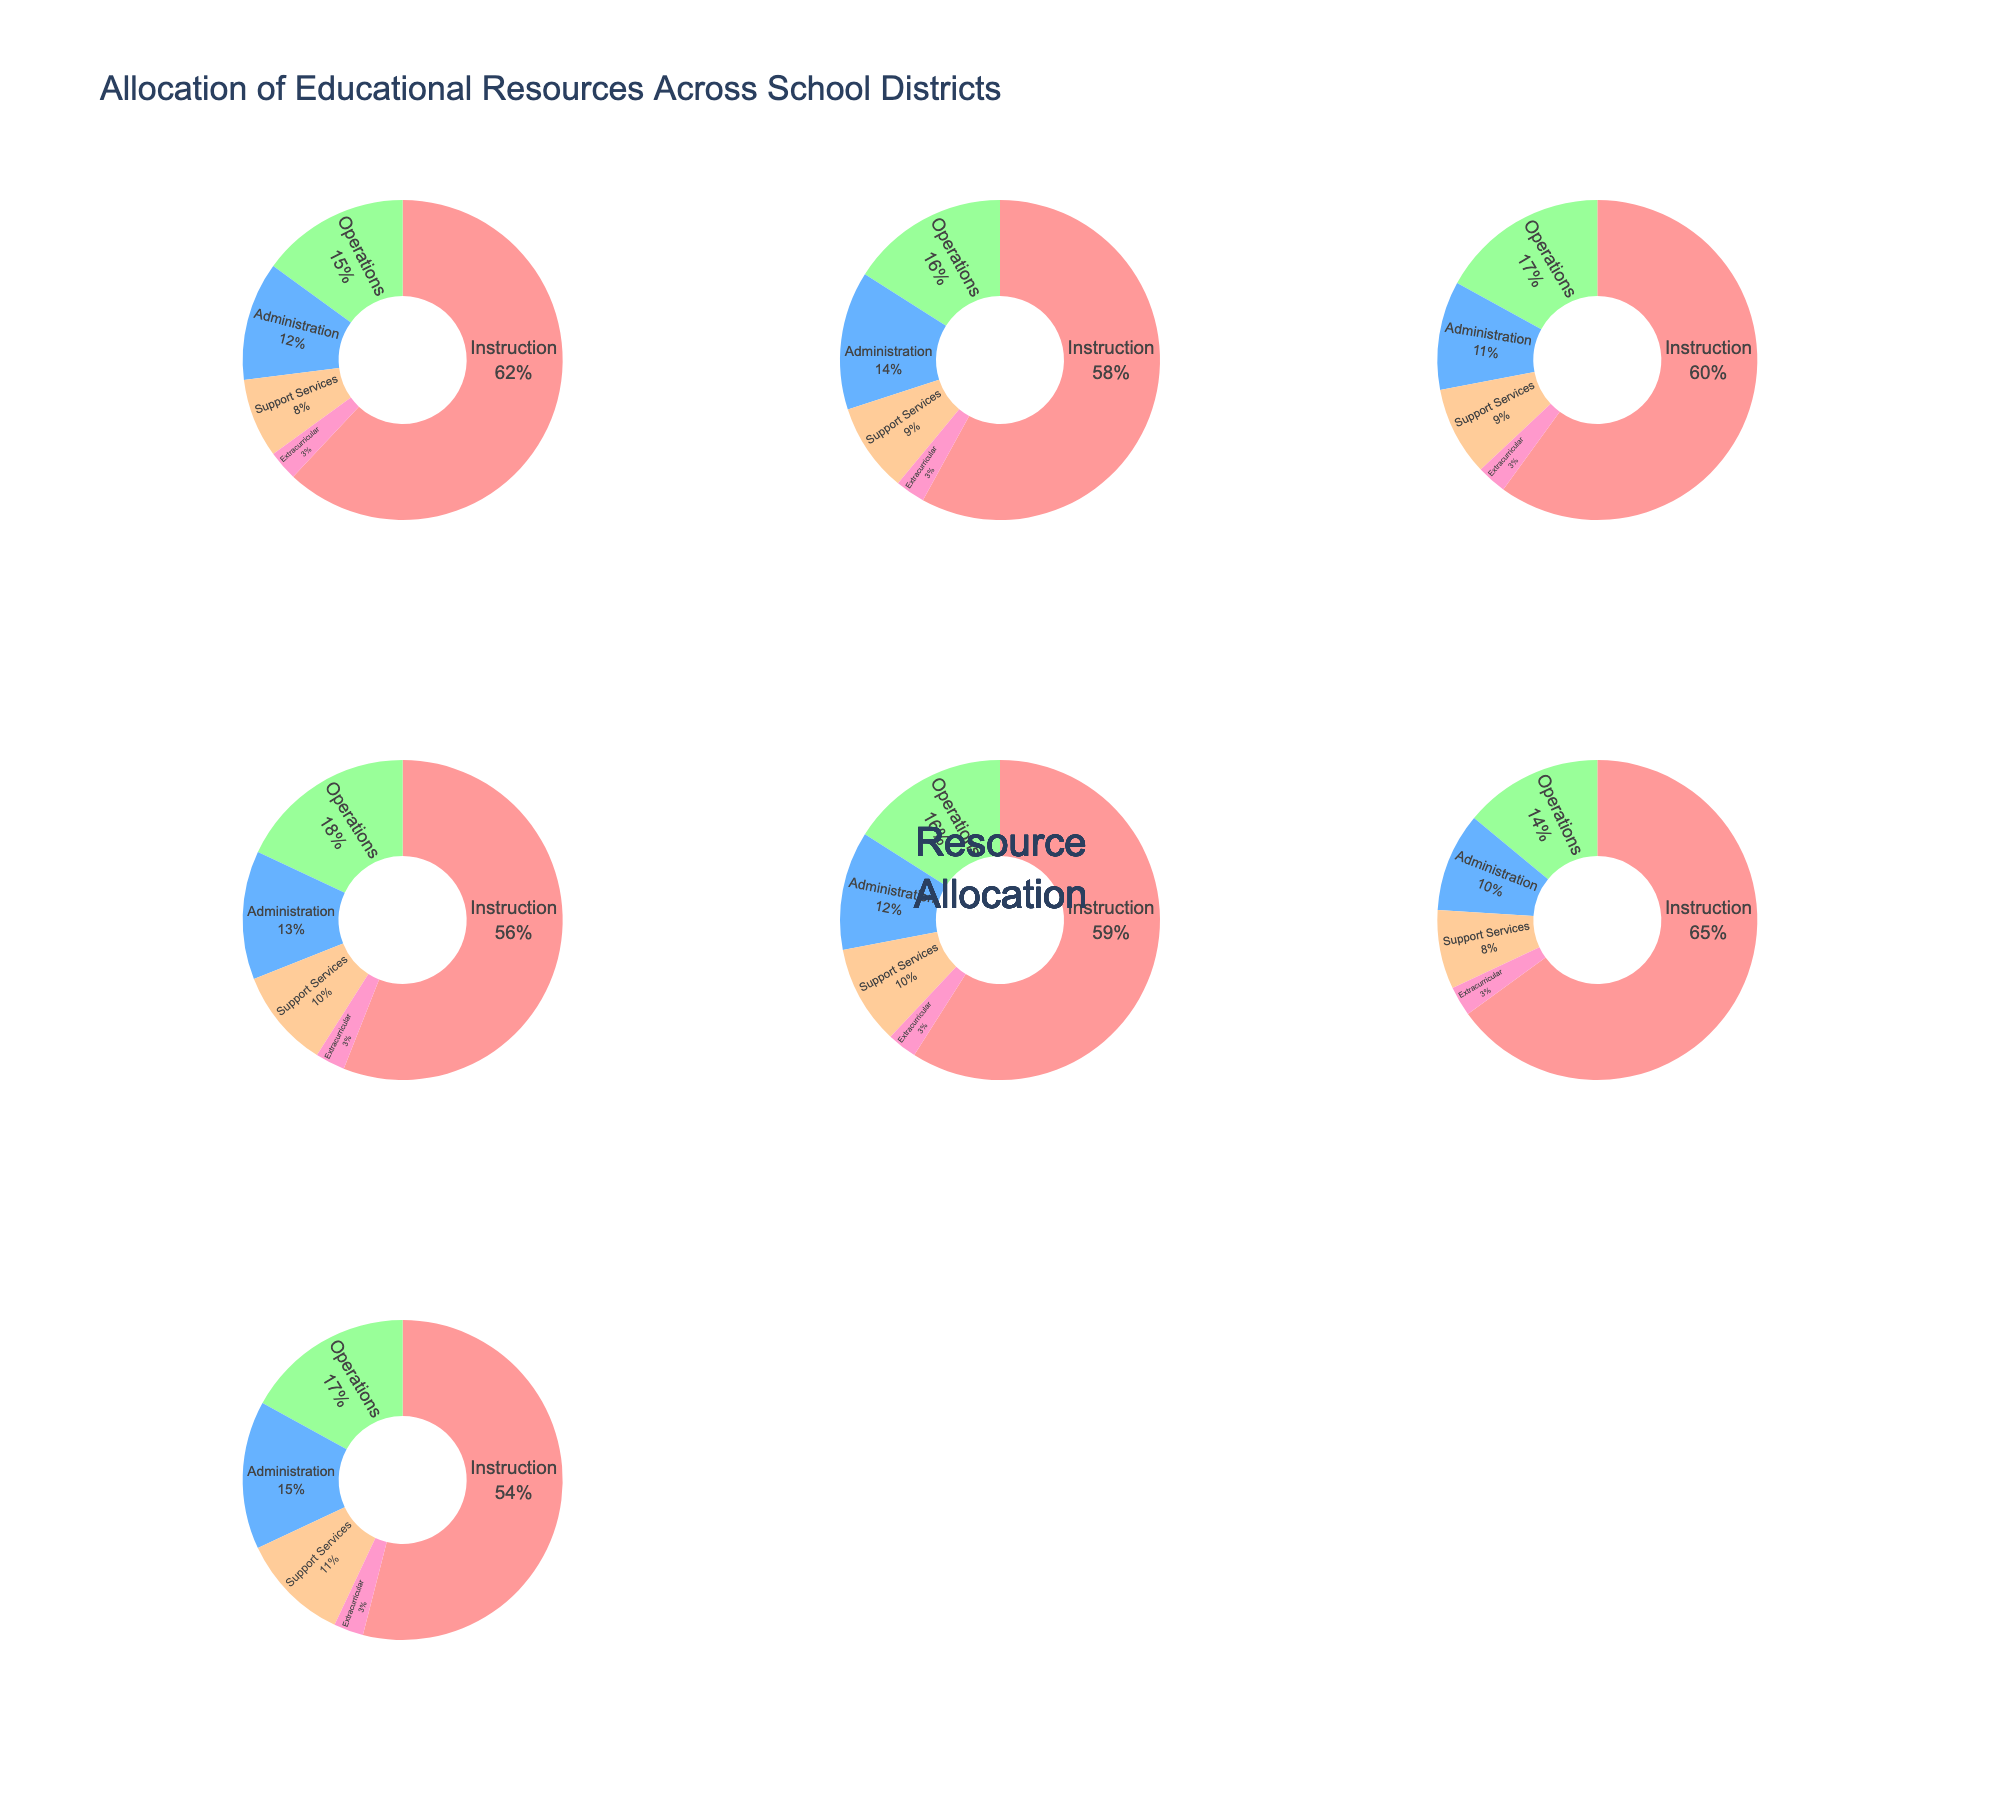What is the title of the figure? The title is located at the top of the figure. Reading it will provide the name of the chart.
Answer: Allocation of Time for IP Lawyers What percentage of time do IP lawyers spend on court appearances? Examine the percentage labeled for court appearances in the pie chart. It is identified with a segment and label.
Answer: 15% Which task takes up the most time for IP lawyers? Identify the task with the largest percentage in either of the two pie charts.
Answer: Legal Research What is the combined percentage of time spent on client meetings and drafting patents? Add the percentages for client meetings (25%) and drafting patents (20%).
Answer: 45% How much more time is spent on legal research than on administrative tasks? Subtract the percentage for administrative tasks (10%) from the percentage for legal research (30%).
Answer: 20% What is the smallest segment in the pie chart? Identify the segment with the lowest percentage value in the pie chart.
Answer: Administrative Tasks How many distinct tasks are represented in the pie charts? Count the different task labels in the pie charts.
Answer: 5 What is the percentage of time spent on tasks other than legal research? Subtract the percentage of time spent on legal research (30%) from 100%.
Answer: 70% Is the percentage of time spent on client meetings greater than that spent on drafting patents? Compare the percentages for client meetings (25%) and drafting patents (20%).
Answer: Yes Which segment is located at the 0-degree mark in the first pie chart? Locate the segment starting at the 0-degree mark by observing the order of segments.
Answer: Client Meetings 